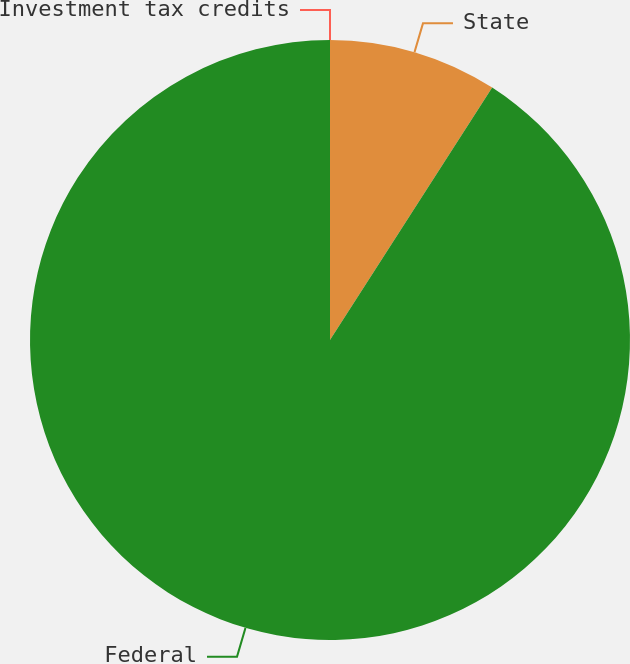<chart> <loc_0><loc_0><loc_500><loc_500><pie_chart><fcel>State<fcel>Federal<fcel>Investment tax credits<nl><fcel>9.09%<fcel>90.9%<fcel>0.0%<nl></chart> 